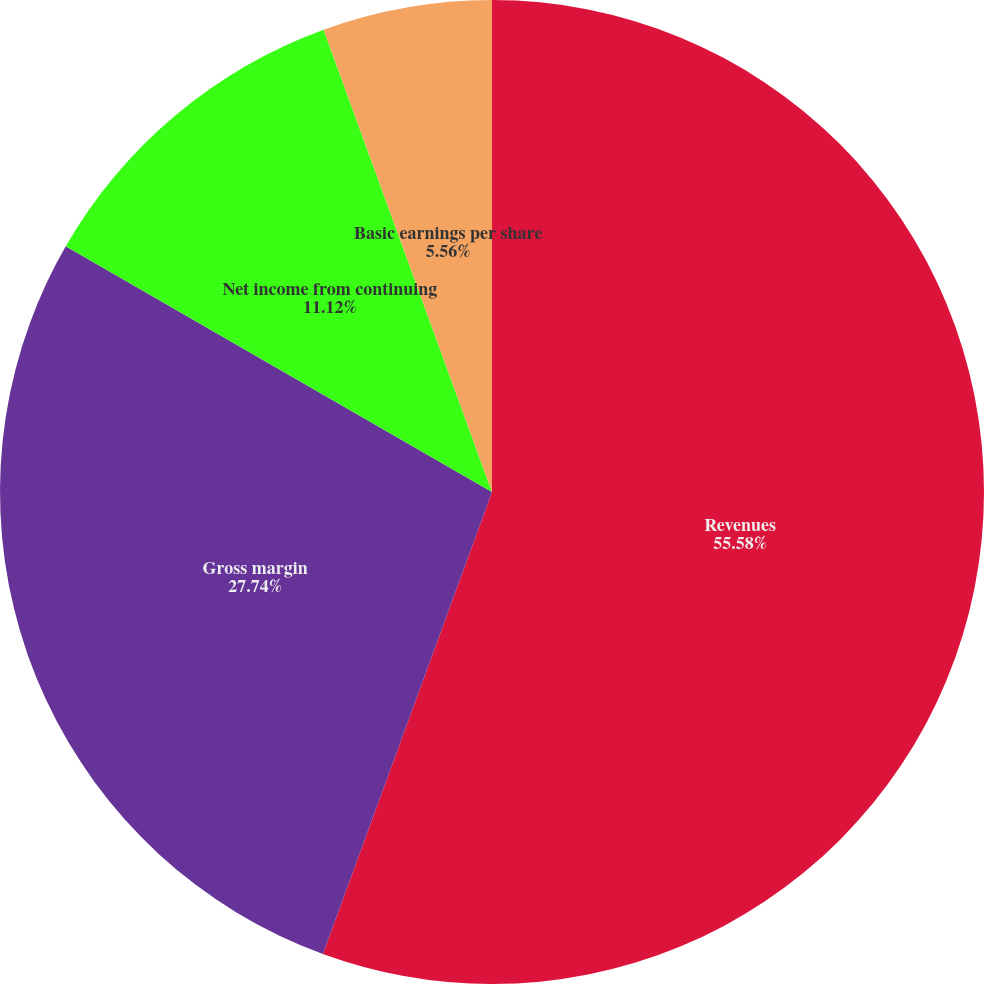<chart> <loc_0><loc_0><loc_500><loc_500><pie_chart><fcel>Revenues<fcel>Gross margin<fcel>Net income from continuing<fcel>Basic earnings per share<fcel>Diluted earnings per share<nl><fcel>55.59%<fcel>27.74%<fcel>11.12%<fcel>5.56%<fcel>0.0%<nl></chart> 